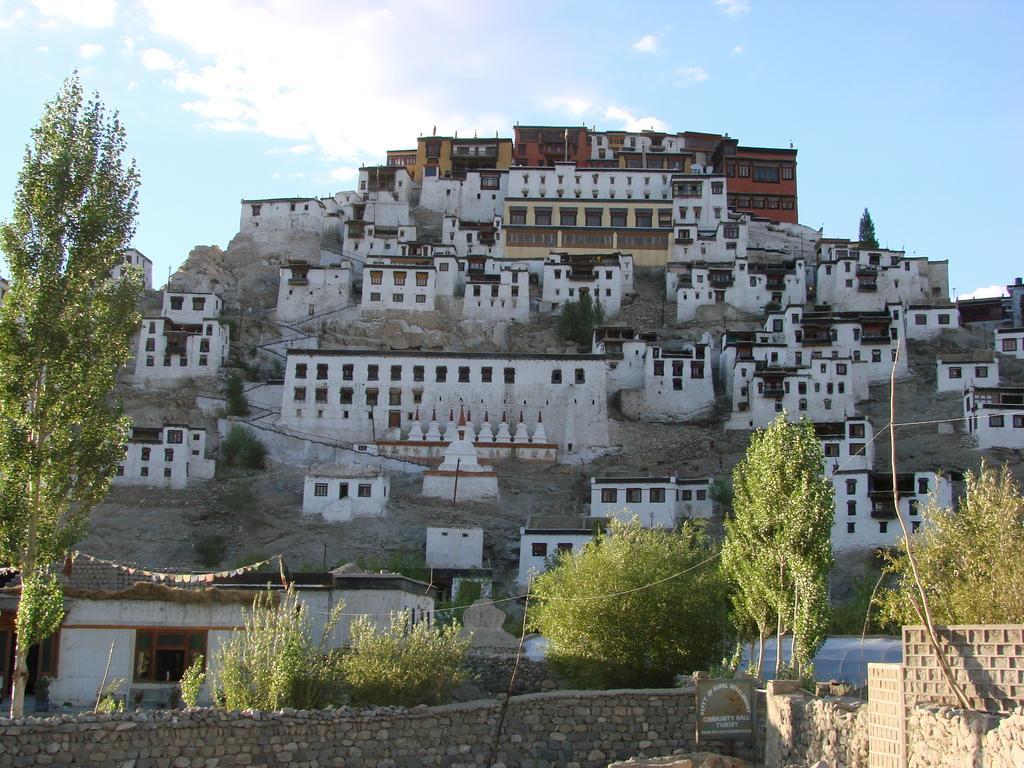Can you describe this image briefly? In the picture I can see the stone wall, trees, houses and the blue color sky with clouds in the background. 